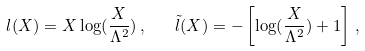Convert formula to latex. <formula><loc_0><loc_0><loc_500><loc_500>l ( X ) = X \log ( \frac { X } { \Lambda ^ { 2 } } ) \, , \quad \tilde { l } ( X ) = - \left [ \log ( \frac { X } { \Lambda ^ { 2 } } ) + 1 \right ] \, ,</formula> 